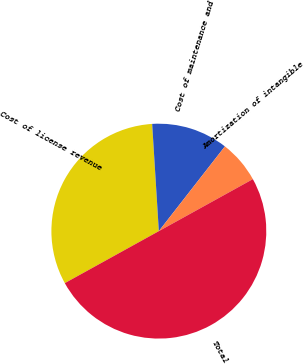Convert chart to OTSL. <chart><loc_0><loc_0><loc_500><loc_500><pie_chart><fcel>Cost of license revenue<fcel>Cost of maintenance and<fcel>Amortization of intangible<fcel>Total<nl><fcel>32.05%<fcel>11.53%<fcel>6.42%<fcel>50.0%<nl></chart> 